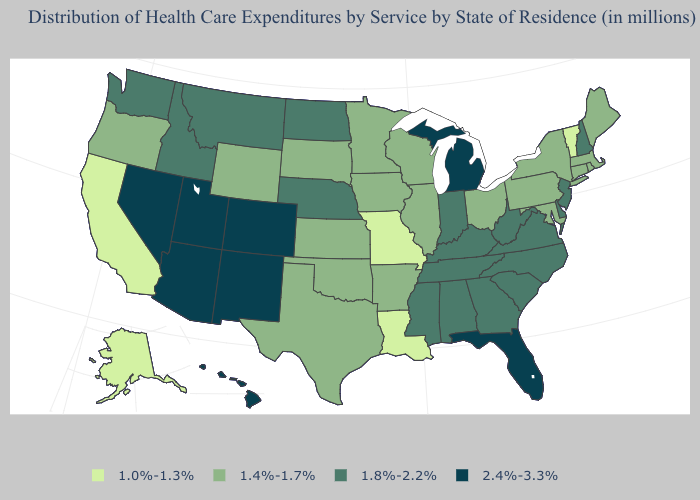Does Ohio have the lowest value in the MidWest?
Be succinct. No. Among the states that border Oklahoma , which have the highest value?
Keep it brief. Colorado, New Mexico. What is the value of Mississippi?
Answer briefly. 1.8%-2.2%. Which states have the lowest value in the Northeast?
Keep it brief. Vermont. What is the highest value in the MidWest ?
Write a very short answer. 2.4%-3.3%. What is the value of Arkansas?
Concise answer only. 1.4%-1.7%. Which states hav the highest value in the South?
Concise answer only. Florida. What is the value of Alaska?
Concise answer only. 1.0%-1.3%. What is the highest value in states that border Delaware?
Quick response, please. 1.8%-2.2%. Does New Mexico have a higher value than West Virginia?
Concise answer only. Yes. What is the value of Georgia?
Be succinct. 1.8%-2.2%. What is the highest value in the South ?
Short answer required. 2.4%-3.3%. Name the states that have a value in the range 1.0%-1.3%?
Give a very brief answer. Alaska, California, Louisiana, Missouri, Vermont. Does New Hampshire have the highest value in the Northeast?
Short answer required. Yes. What is the value of Hawaii?
Keep it brief. 2.4%-3.3%. 